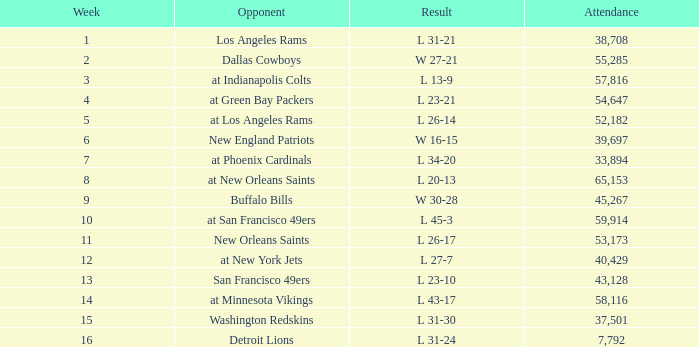On September 10, 1989 how many people attended the game? 38708.0. 